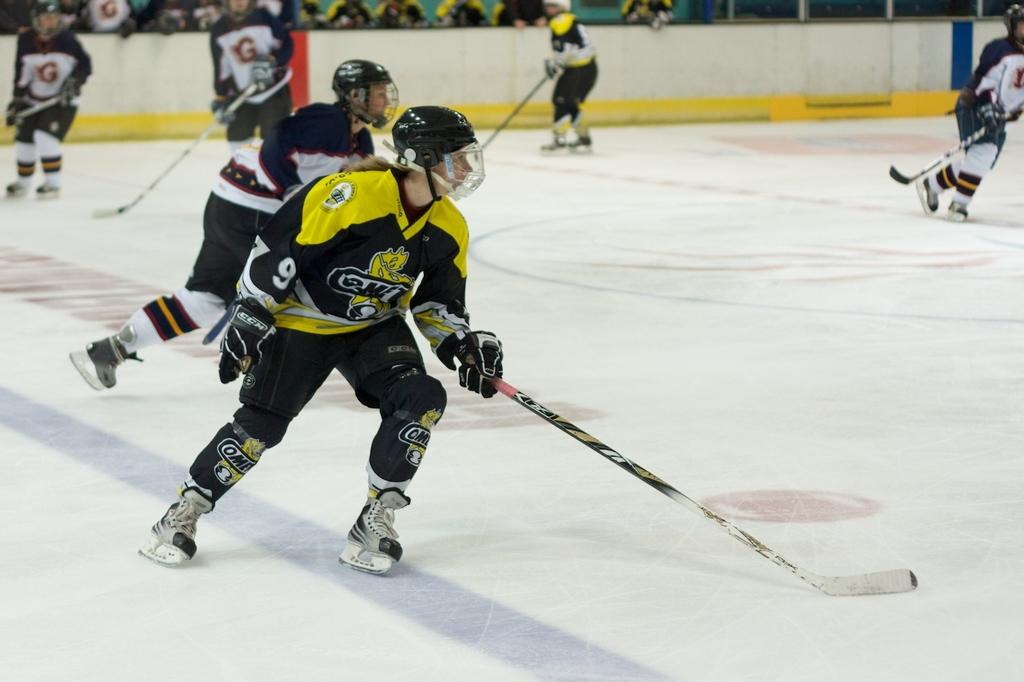What activity are the people in the image engaged in? People are playing snow hockey in the image. What equipment are the people using to play snow hockey? The people are holding hockey sticks. What protective gear are the people wearing? The people are wearing helmets. What can be seen in the background of the image? There are people visible in the background of the image, and there is a wall in the background as well. What type of fog can be seen in the image? There is no fog present in the image; it is a clear scene of people playing snow hockey. 